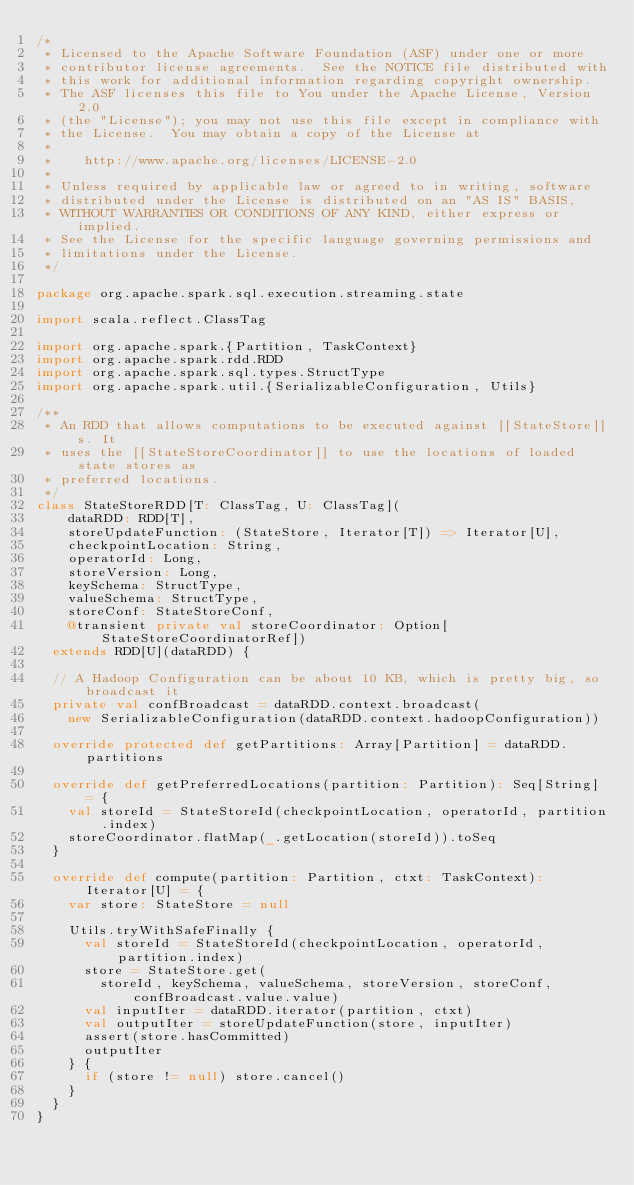<code> <loc_0><loc_0><loc_500><loc_500><_Scala_>/*
 * Licensed to the Apache Software Foundation (ASF) under one or more
 * contributor license agreements.  See the NOTICE file distributed with
 * this work for additional information regarding copyright ownership.
 * The ASF licenses this file to You under the Apache License, Version 2.0
 * (the "License"); you may not use this file except in compliance with
 * the License.  You may obtain a copy of the License at
 *
 *    http://www.apache.org/licenses/LICENSE-2.0
 *
 * Unless required by applicable law or agreed to in writing, software
 * distributed under the License is distributed on an "AS IS" BASIS,
 * WITHOUT WARRANTIES OR CONDITIONS OF ANY KIND, either express or implied.
 * See the License for the specific language governing permissions and
 * limitations under the License.
 */

package org.apache.spark.sql.execution.streaming.state

import scala.reflect.ClassTag

import org.apache.spark.{Partition, TaskContext}
import org.apache.spark.rdd.RDD
import org.apache.spark.sql.types.StructType
import org.apache.spark.util.{SerializableConfiguration, Utils}

/**
 * An RDD that allows computations to be executed against [[StateStore]]s. It
 * uses the [[StateStoreCoordinator]] to use the locations of loaded state stores as
 * preferred locations.
 */
class StateStoreRDD[T: ClassTag, U: ClassTag](
    dataRDD: RDD[T],
    storeUpdateFunction: (StateStore, Iterator[T]) => Iterator[U],
    checkpointLocation: String,
    operatorId: Long,
    storeVersion: Long,
    keySchema: StructType,
    valueSchema: StructType,
    storeConf: StateStoreConf,
    @transient private val storeCoordinator: Option[StateStoreCoordinatorRef])
  extends RDD[U](dataRDD) {

  // A Hadoop Configuration can be about 10 KB, which is pretty big, so broadcast it
  private val confBroadcast = dataRDD.context.broadcast(
    new SerializableConfiguration(dataRDD.context.hadoopConfiguration))

  override protected def getPartitions: Array[Partition] = dataRDD.partitions

  override def getPreferredLocations(partition: Partition): Seq[String] = {
    val storeId = StateStoreId(checkpointLocation, operatorId, partition.index)
    storeCoordinator.flatMap(_.getLocation(storeId)).toSeq
  }

  override def compute(partition: Partition, ctxt: TaskContext): Iterator[U] = {
    var store: StateStore = null

    Utils.tryWithSafeFinally {
      val storeId = StateStoreId(checkpointLocation, operatorId, partition.index)
      store = StateStore.get(
        storeId, keySchema, valueSchema, storeVersion, storeConf, confBroadcast.value.value)
      val inputIter = dataRDD.iterator(partition, ctxt)
      val outputIter = storeUpdateFunction(store, inputIter)
      assert(store.hasCommitted)
      outputIter
    } {
      if (store != null) store.cancel()
    }
  }
}
</code> 